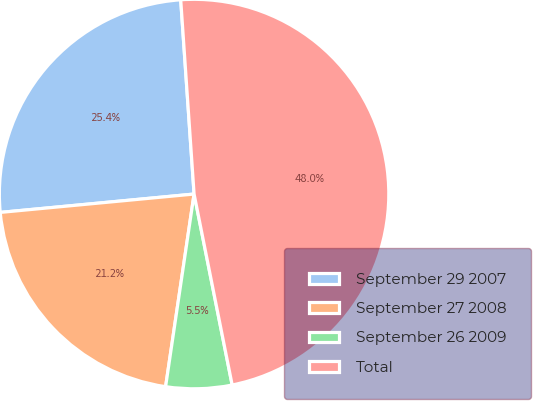Convert chart. <chart><loc_0><loc_0><loc_500><loc_500><pie_chart><fcel>September 29 2007<fcel>September 27 2008<fcel>September 26 2009<fcel>Total<nl><fcel>25.41%<fcel>21.16%<fcel>5.47%<fcel>47.96%<nl></chart> 